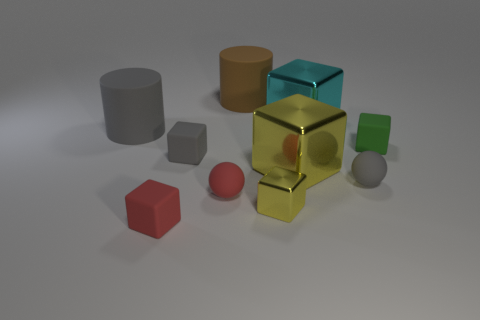Subtract all green cubes. How many cubes are left? 5 Subtract all small gray blocks. How many blocks are left? 5 Subtract 3 cubes. How many cubes are left? 3 Subtract all blue blocks. Subtract all purple cylinders. How many blocks are left? 6 Subtract all cylinders. How many objects are left? 8 Subtract 1 red blocks. How many objects are left? 9 Subtract all metal blocks. Subtract all cyan objects. How many objects are left? 6 Add 8 large metallic blocks. How many large metallic blocks are left? 10 Add 5 tiny gray matte cubes. How many tiny gray matte cubes exist? 6 